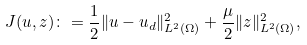Convert formula to latex. <formula><loc_0><loc_0><loc_500><loc_500>J ( u , z ) \colon = \frac { 1 } { 2 } \| u - u _ { d } \| _ { L ^ { 2 } ( \Omega ) } ^ { 2 } + \frac { \mu } { 2 } \| z \| _ { L ^ { 2 } ( \Omega ) } ^ { 2 } ,</formula> 